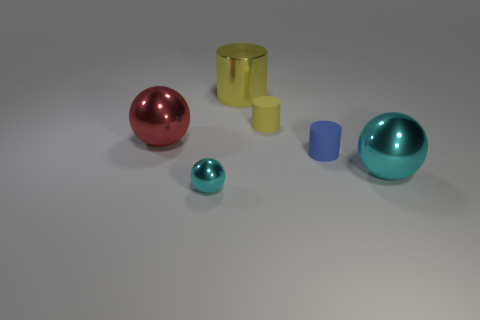What number of tiny objects are either red metal things or brown rubber balls?
Offer a terse response. 0. Are there any other things that are the same color as the metallic cylinder?
Provide a succinct answer. Yes. Does the cylinder in front of the red sphere have the same size as the big cyan metal object?
Keep it short and to the point. No. What color is the metallic sphere that is behind the cyan shiny object on the right side of the cyan shiny object that is left of the large yellow thing?
Your response must be concise. Red. The shiny cylinder is what color?
Offer a terse response. Yellow. Does the big metallic cylinder have the same color as the tiny shiny object?
Offer a very short reply. No. Is the large sphere right of the red ball made of the same material as the blue thing that is in front of the metallic cylinder?
Ensure brevity in your answer.  No. There is another cyan thing that is the same shape as the big cyan shiny thing; what is it made of?
Your response must be concise. Metal. Is the red thing made of the same material as the big yellow thing?
Provide a succinct answer. Yes. What color is the ball to the right of the small matte cylinder that is in front of the big red shiny object?
Offer a terse response. Cyan. 